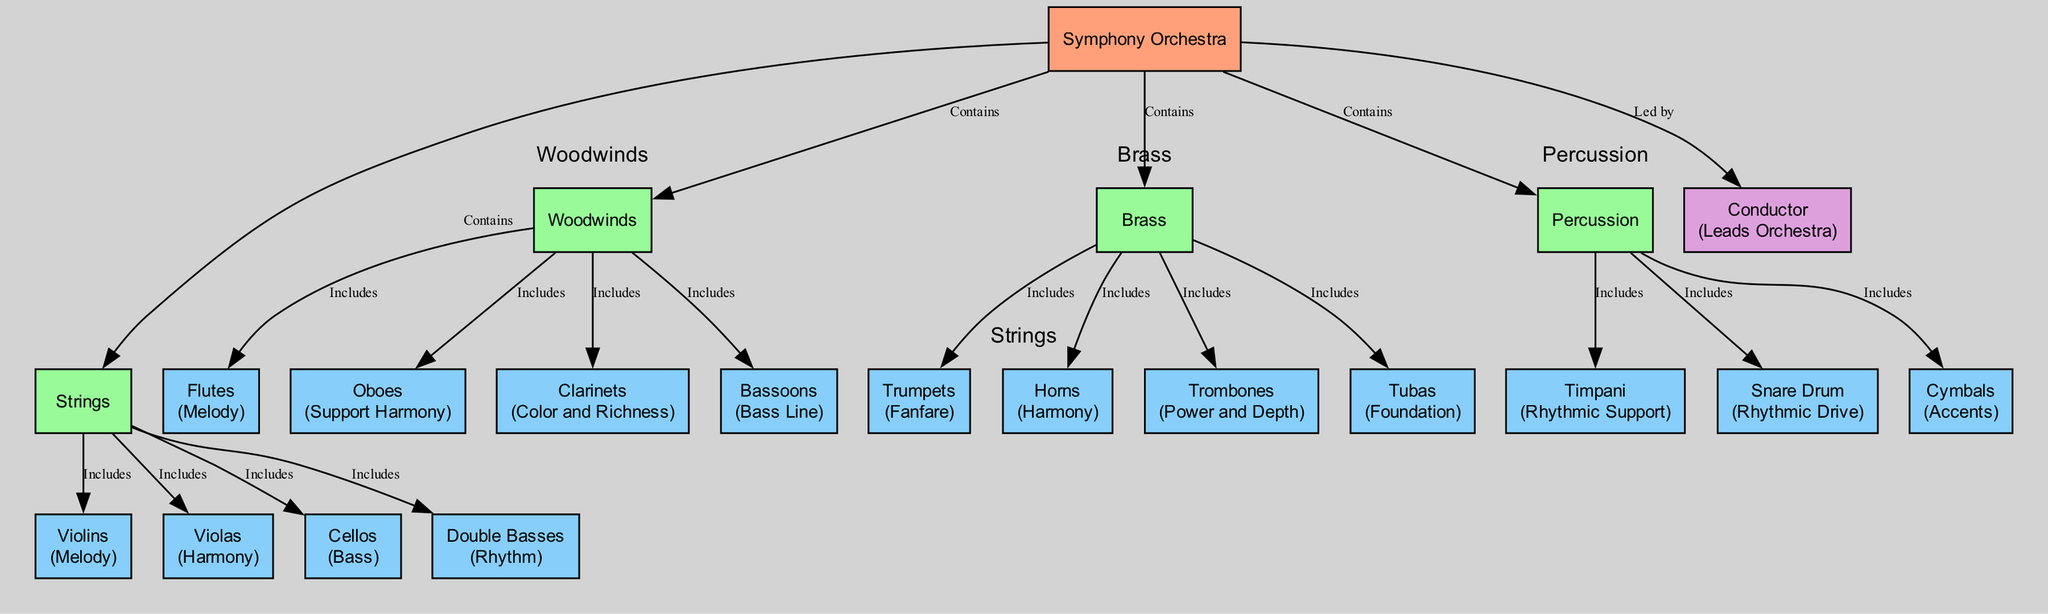What is the main entity represented in the diagram? The diagram represents a "Symphony Orchestra" as the main entity. This is found at the top level of the diagram and acts as a container for all other sections and instruments.
Answer: Symphony Orchestra How many sections are there in the symphony orchestra? The diagram indicates that there are four main sections: Strings, Woodwinds, Brass, and Percussion. These sections are clearly depicted as separate areas connected to the main entity.
Answer: Four What key role do violas play in the orchestra? According to the diagram, violas have the key role of "Harmony," which is stated in their properties. This information can be found by examining the subsection label for violas.
Answer: Harmony Which section includes the flute? The diagram shows that the flute is included in the "Woodwinds" section. The relationship can be established by tracing the connection from the flute node to the Woodwinds section in the diagram.
Answer: Woodwinds What is the key role of trumpets? The diagram attributes the key role of "Fanfare" to the trumpets, which is specified in their properties section. To find this, one needs to identify the trumpet node and read its key role information.
Answer: Fanfare Which instrument provides "Rhythmic Drive" in the orchestra? The Snare Drum is designated as providing "Rhythmic Drive," as indicated in its properties within the diagram. The answer is obtained by locating the Snare Drum subsection and noting its assigned key role.
Answer: Snare Drum What relationship does the conductor have with the orchestra? The conductor is shown in the diagram as "Leads Orchestra," which indicates their role in relation to the symphony orchestra. This can be identified by following the edge that connects the conductor node to the main orchestra entity.
Answer: Leads Orchestra How many types of instruments are shown in the Brass section? The diagram illustrates four instruments within the Brass section: Trumpets, Horns, Trombones, and Tubas. By counting the number of subsections connected to the Brass section, this answer can be determined.
Answer: Four Which section contains the Bassoons? The Bassoons are included in the "Woodwinds" section of the orchestra, as indicated in the diagram by the connection from the Bassoons to the Woodwinds section.
Answer: Woodwinds 